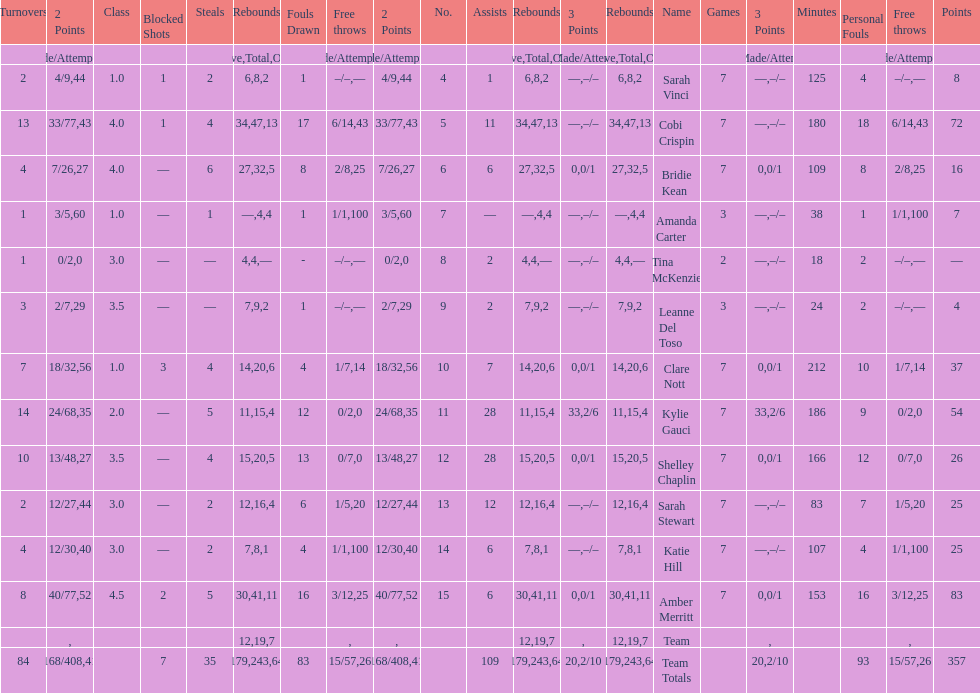Who is the first person on the list to play less than 20 minutes? Tina McKenzie. 